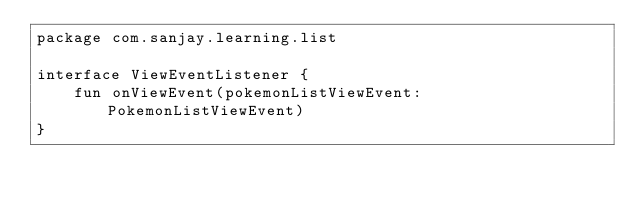Convert code to text. <code><loc_0><loc_0><loc_500><loc_500><_Kotlin_>package com.sanjay.learning.list

interface ViewEventListener {
    fun onViewEvent(pokemonListViewEvent: PokemonListViewEvent)
}
</code> 